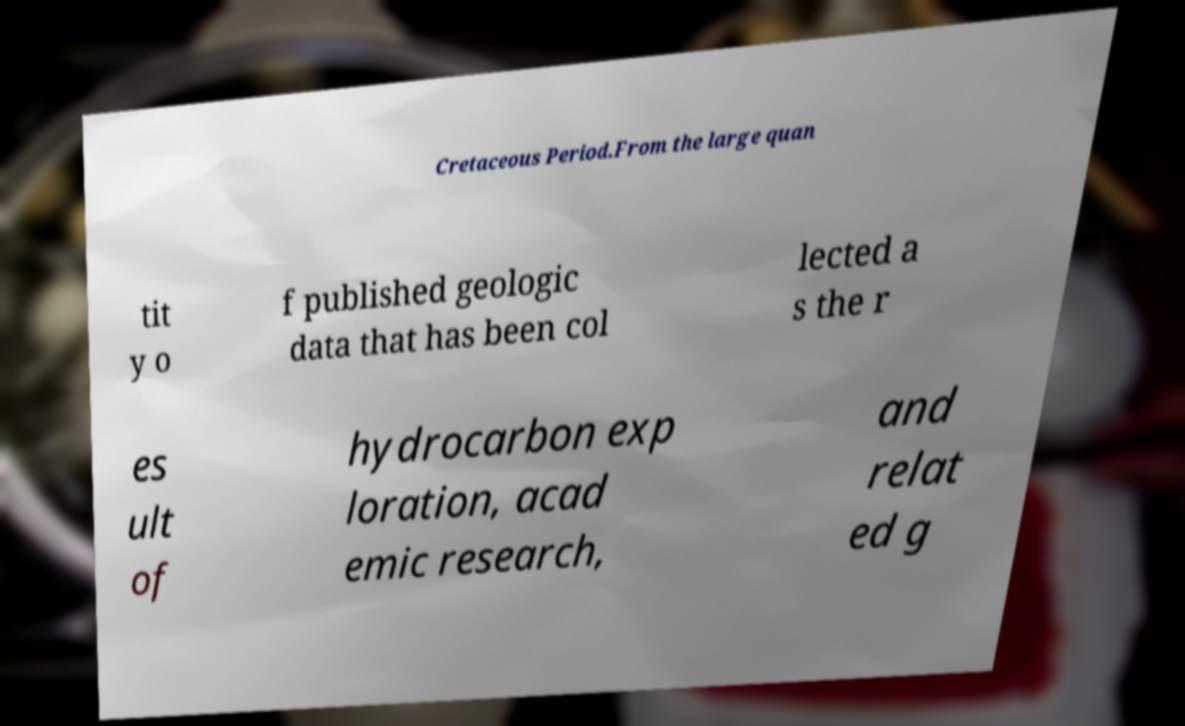Please identify and transcribe the text found in this image. Cretaceous Period.From the large quan tit y o f published geologic data that has been col lected a s the r es ult of hydrocarbon exp loration, acad emic research, and relat ed g 